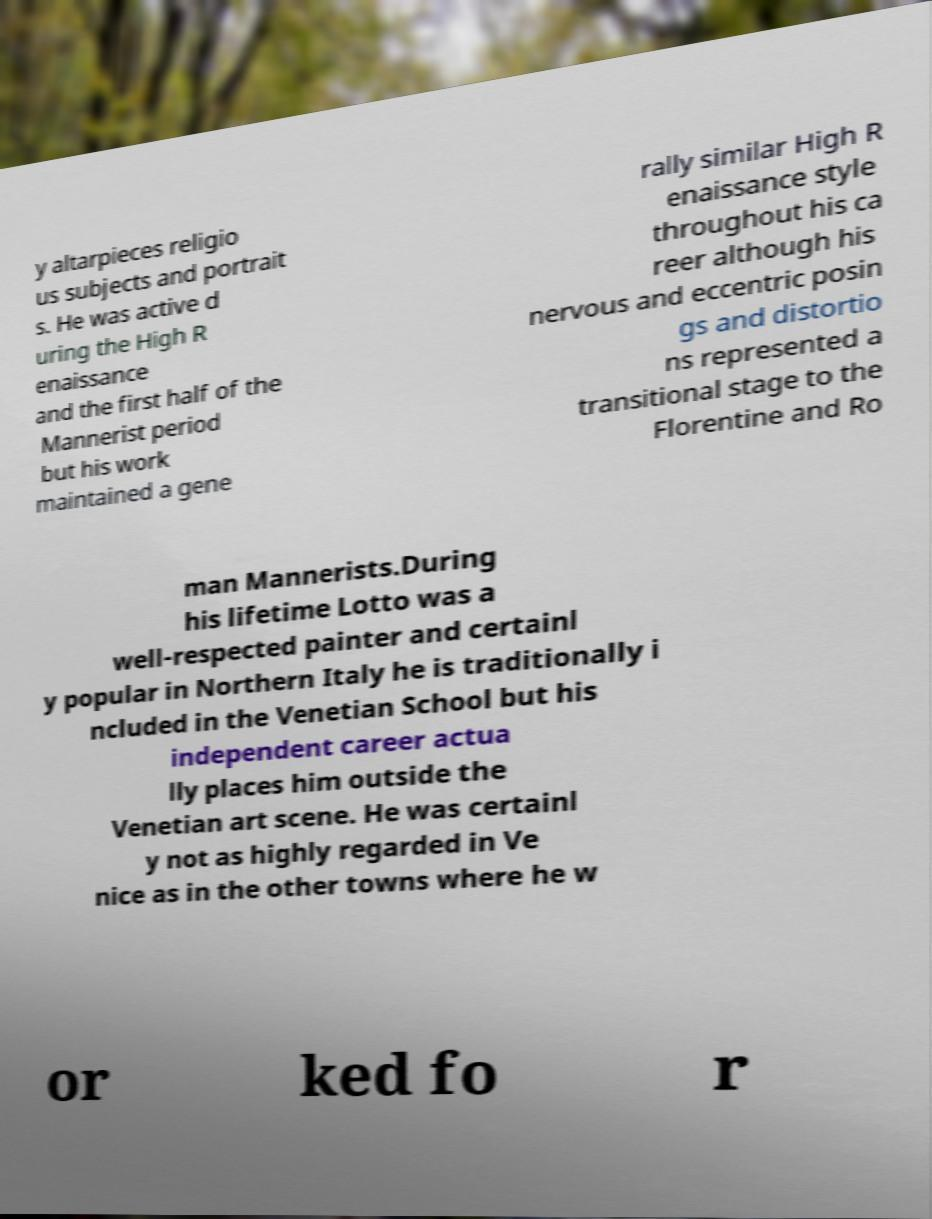Could you assist in decoding the text presented in this image and type it out clearly? y altarpieces religio us subjects and portrait s. He was active d uring the High R enaissance and the first half of the Mannerist period but his work maintained a gene rally similar High R enaissance style throughout his ca reer although his nervous and eccentric posin gs and distortio ns represented a transitional stage to the Florentine and Ro man Mannerists.During his lifetime Lotto was a well-respected painter and certainl y popular in Northern Italy he is traditionally i ncluded in the Venetian School but his independent career actua lly places him outside the Venetian art scene. He was certainl y not as highly regarded in Ve nice as in the other towns where he w or ked fo r 